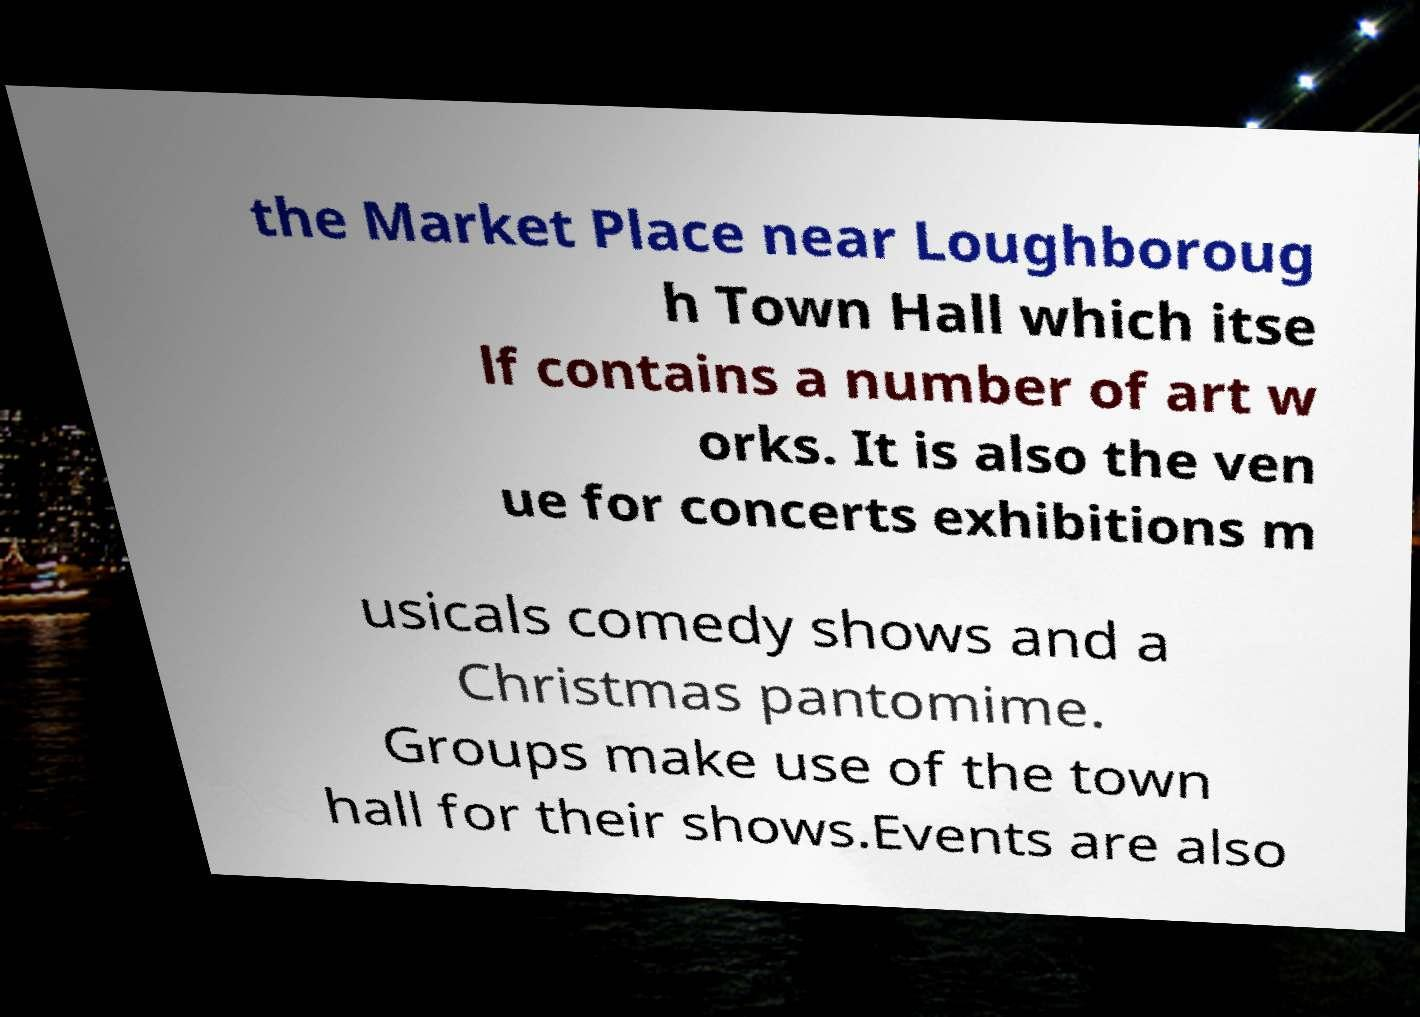Can you accurately transcribe the text from the provided image for me? the Market Place near Loughboroug h Town Hall which itse lf contains a number of art w orks. It is also the ven ue for concerts exhibitions m usicals comedy shows and a Christmas pantomime. Groups make use of the town hall for their shows.Events are also 